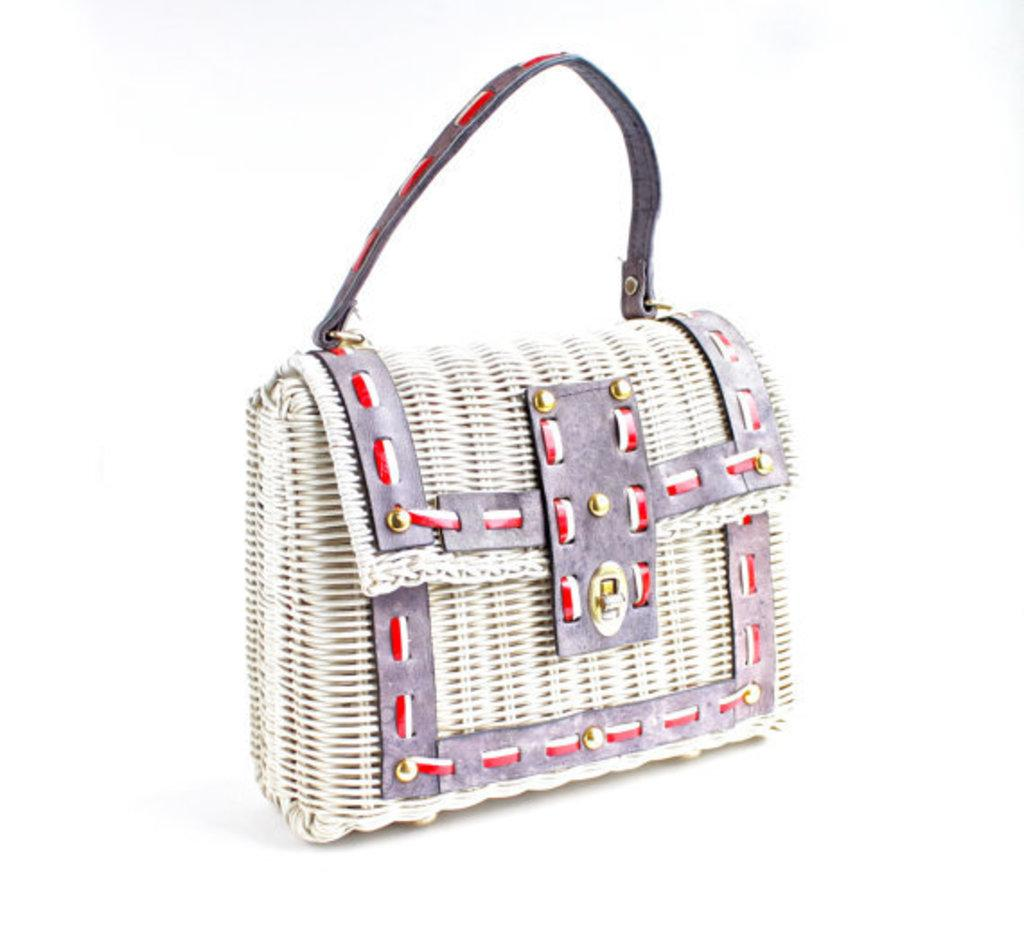What type of setting is depicted in the image? The image is of an indoor scene. What object can be seen in the foreground of the image? There is a purse placed on a surface in the foreground. What color is the background of the image? The background of the image is white in color. Can you see a crow flying in the image? There is no crow present in the image. What type of truck is visible in the background of the image? There is no truck present in the image; it is an indoor scene with a white background. 